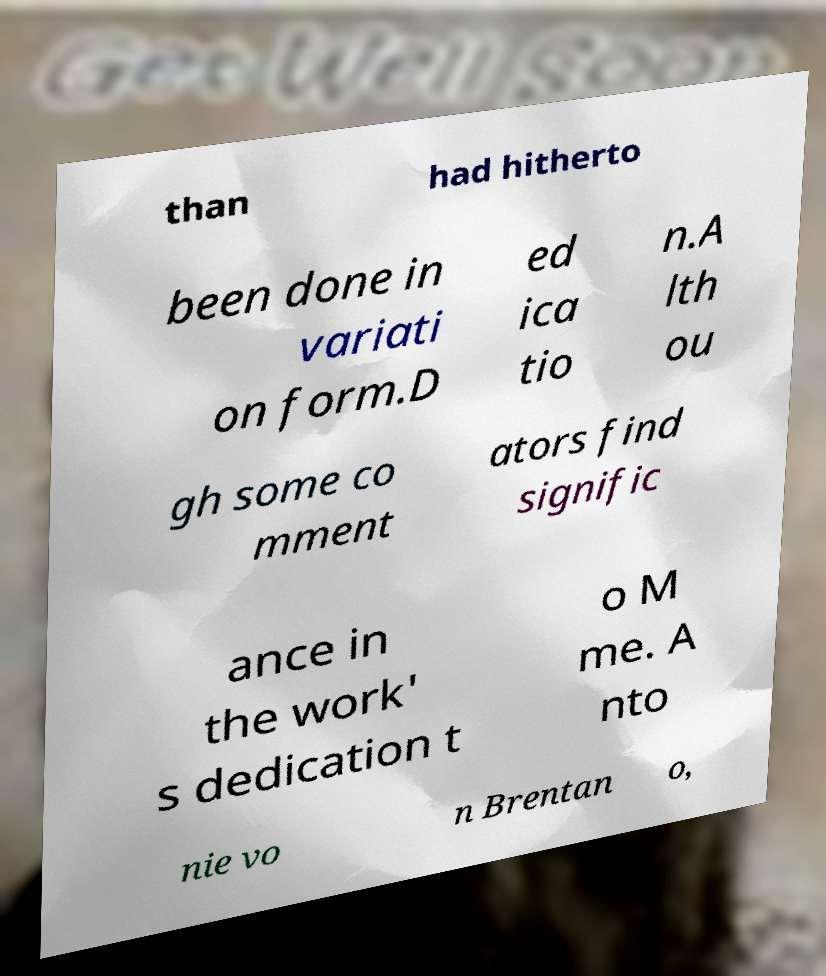What messages or text are displayed in this image? I need them in a readable, typed format. than had hitherto been done in variati on form.D ed ica tio n.A lth ou gh some co mment ators find signific ance in the work' s dedication t o M me. A nto nie vo n Brentan o, 